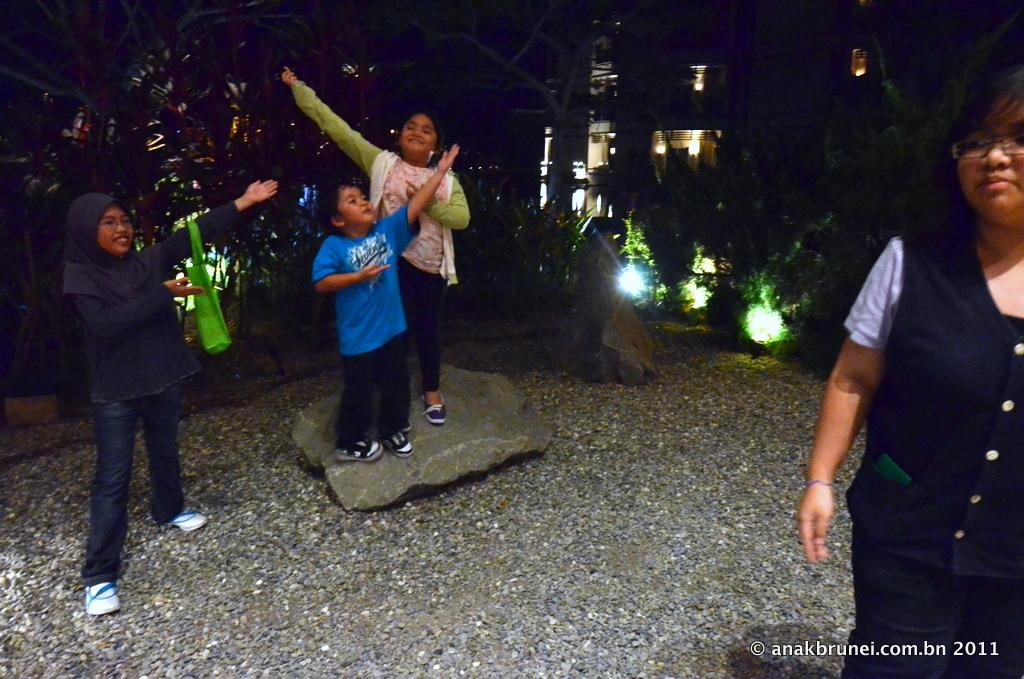What are the children in the image doing? The children are playing in the image. What can be seen in the background of the image? There are trees and buildings visible in the background of the image. What type of lighting is present in the image? Colorful lights are present in the image. What type of cracker is being used by the children to play in the image? There is no cracker present in the image; the children are playing without any crackers. 